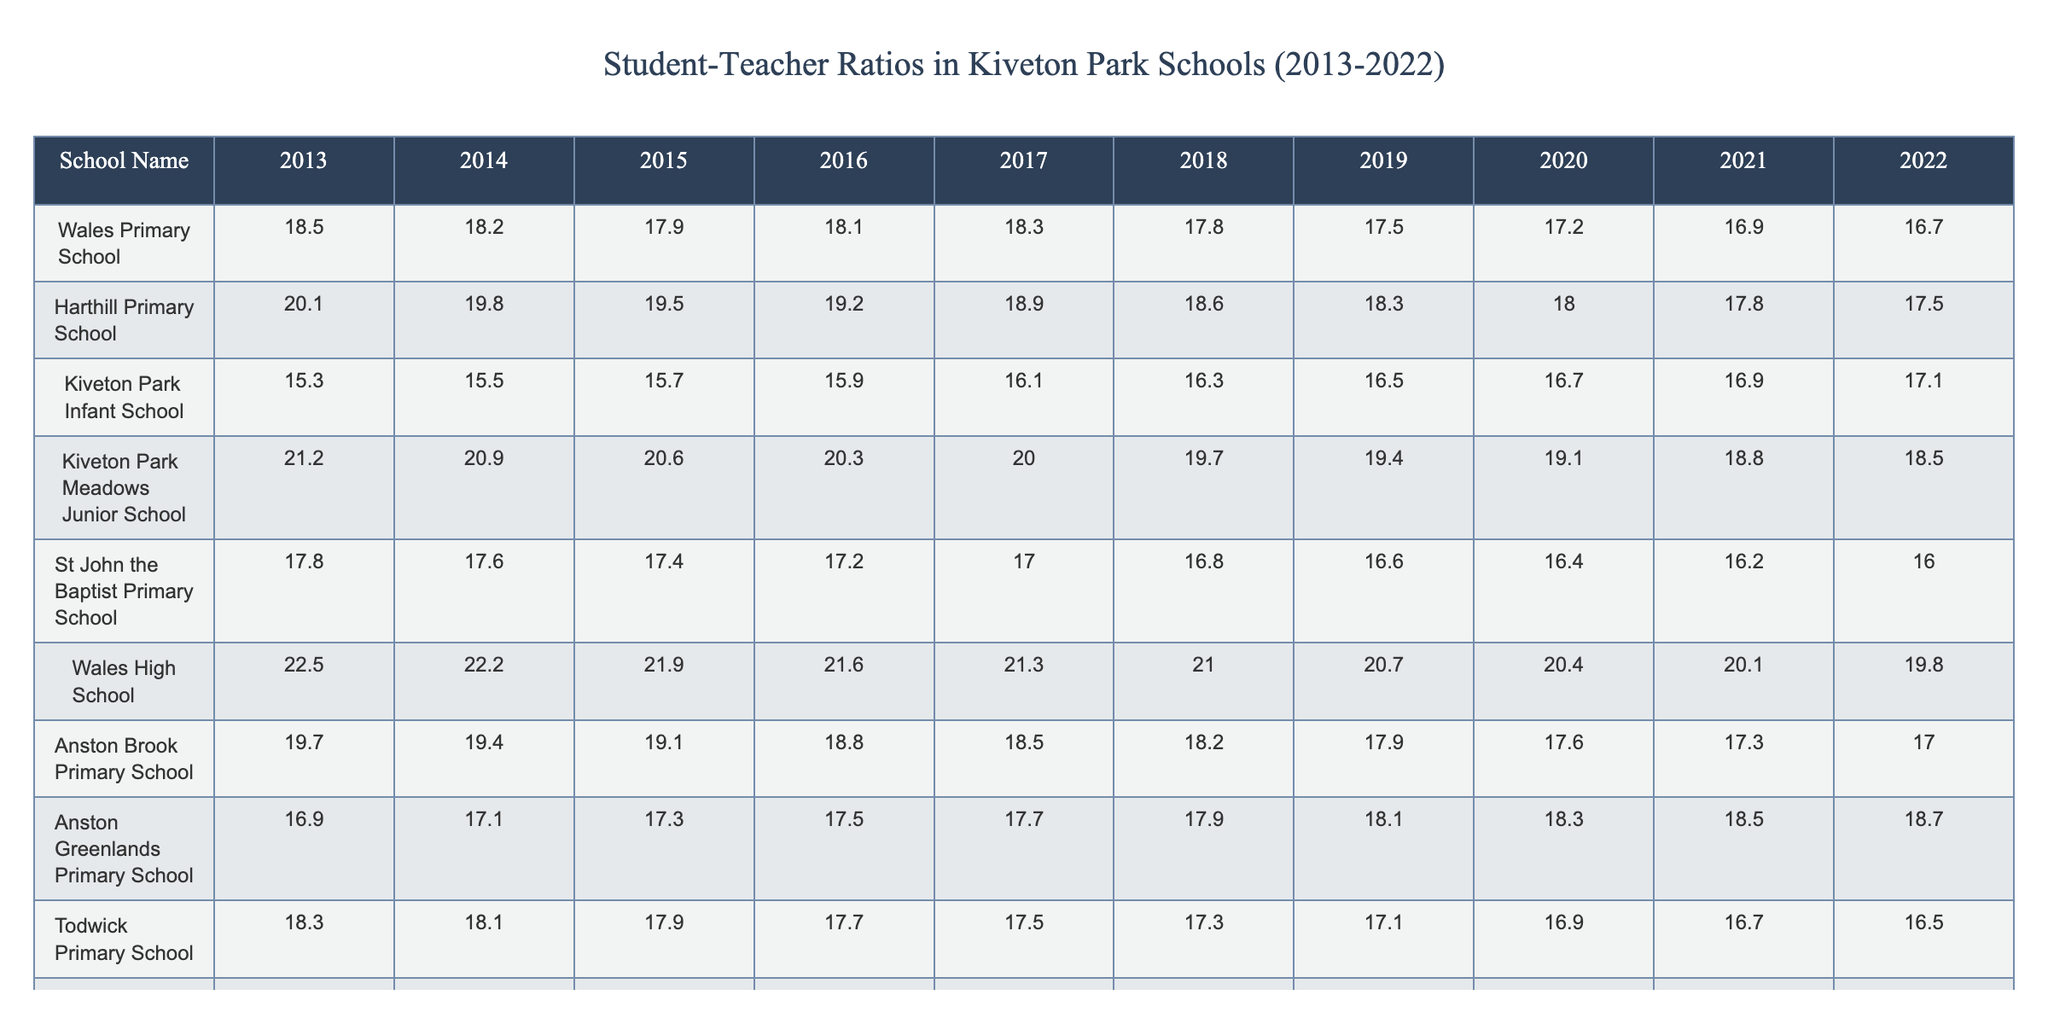What is the student-teacher ratio at Kiveton Park Infant School in 2022? The table lists the student-teacher ratios for Kiveton Park Infant School, and for the year 2022, the value is 17.1.
Answer: 17.1 Which school had the highest student-teacher ratio in 2013? By examining the values for 2013, Wales High School has the highest ratio at 22.5.
Answer: Wales High School What was the trend for the student-teacher ratio at Wales Primary School over the decade? Looking at the values from 2013 to 2022, Wales Primary School started with 18.5 and decreased each year to finish at 16.7, indicating a downward trend.
Answer: Decreasing What is the average student-teacher ratio at Harthill Primary School for the years 2020 to 2022? The ratios for Harthill Primary School in these years are 18.0, 17.8, and 17.5. The sum is 53.3, and dividing by 3 yields an average of 17.77.
Answer: 17.77 Did any school improve its student-teacher ratio every year from 2013 to 2022? By checking the trends for each school, Kiveton Park Infant School shows an improvement as the ratio consistently increases year by year, from 15.3 in 2013 to 17.1 in 2022.
Answer: Yes What is the difference in the student-teacher ratio between Dinnington Community Primary School in 2013 and 2022? The ratio for Dinnington Community Primary School in 2013 is 20.8 and in 2022 is 18.1. The difference is 20.8 - 18.1 = 2.7.
Answer: 2.7 Which school had the lowest student-teacher ratio in 2022, and what was that ratio? Checking the values for 2022 across all schools, Kiveton Park Infant School had the lowest ratio at 17.1.
Answer: Kiveton Park Infant School, 17.1 What is the overall trend for student-teacher ratios in all schools from 2013 to 2022? By analyzing the data, we see that many schools, including Wales Primary School and St John the Baptist Primary School, show a general decrease in their ratios over the decade, suggesting an overall decreasing trend.
Answer: Decreasing trend Which year saw the highest average student-teacher ratio across all schools? Calculating the average for each year reveals that 2013 had the highest average of 19.85 among all schools.
Answer: 2013 Is the student-teacher ratio at Anston Greenlands Primary School higher in 2022 compared to Kiveton Park Meadows Junior School's ratio in the same year? In 2022, Anston Greenlands Primary School's ratio is 18.7 while Kiveton Park Meadows Junior School's ratio is 18.5, thus Anston Greenlands has a higher ratio.
Answer: Yes 